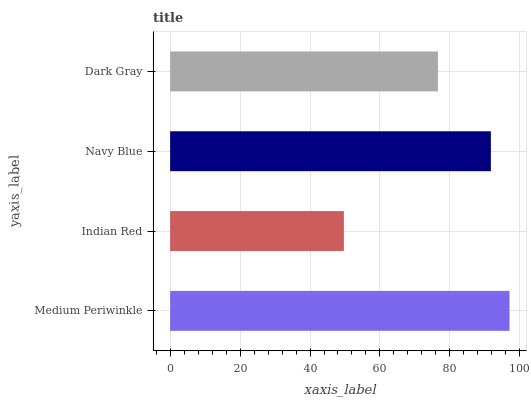Is Indian Red the minimum?
Answer yes or no. Yes. Is Medium Periwinkle the maximum?
Answer yes or no. Yes. Is Navy Blue the minimum?
Answer yes or no. No. Is Navy Blue the maximum?
Answer yes or no. No. Is Navy Blue greater than Indian Red?
Answer yes or no. Yes. Is Indian Red less than Navy Blue?
Answer yes or no. Yes. Is Indian Red greater than Navy Blue?
Answer yes or no. No. Is Navy Blue less than Indian Red?
Answer yes or no. No. Is Navy Blue the high median?
Answer yes or no. Yes. Is Dark Gray the low median?
Answer yes or no. Yes. Is Dark Gray the high median?
Answer yes or no. No. Is Medium Periwinkle the low median?
Answer yes or no. No. 